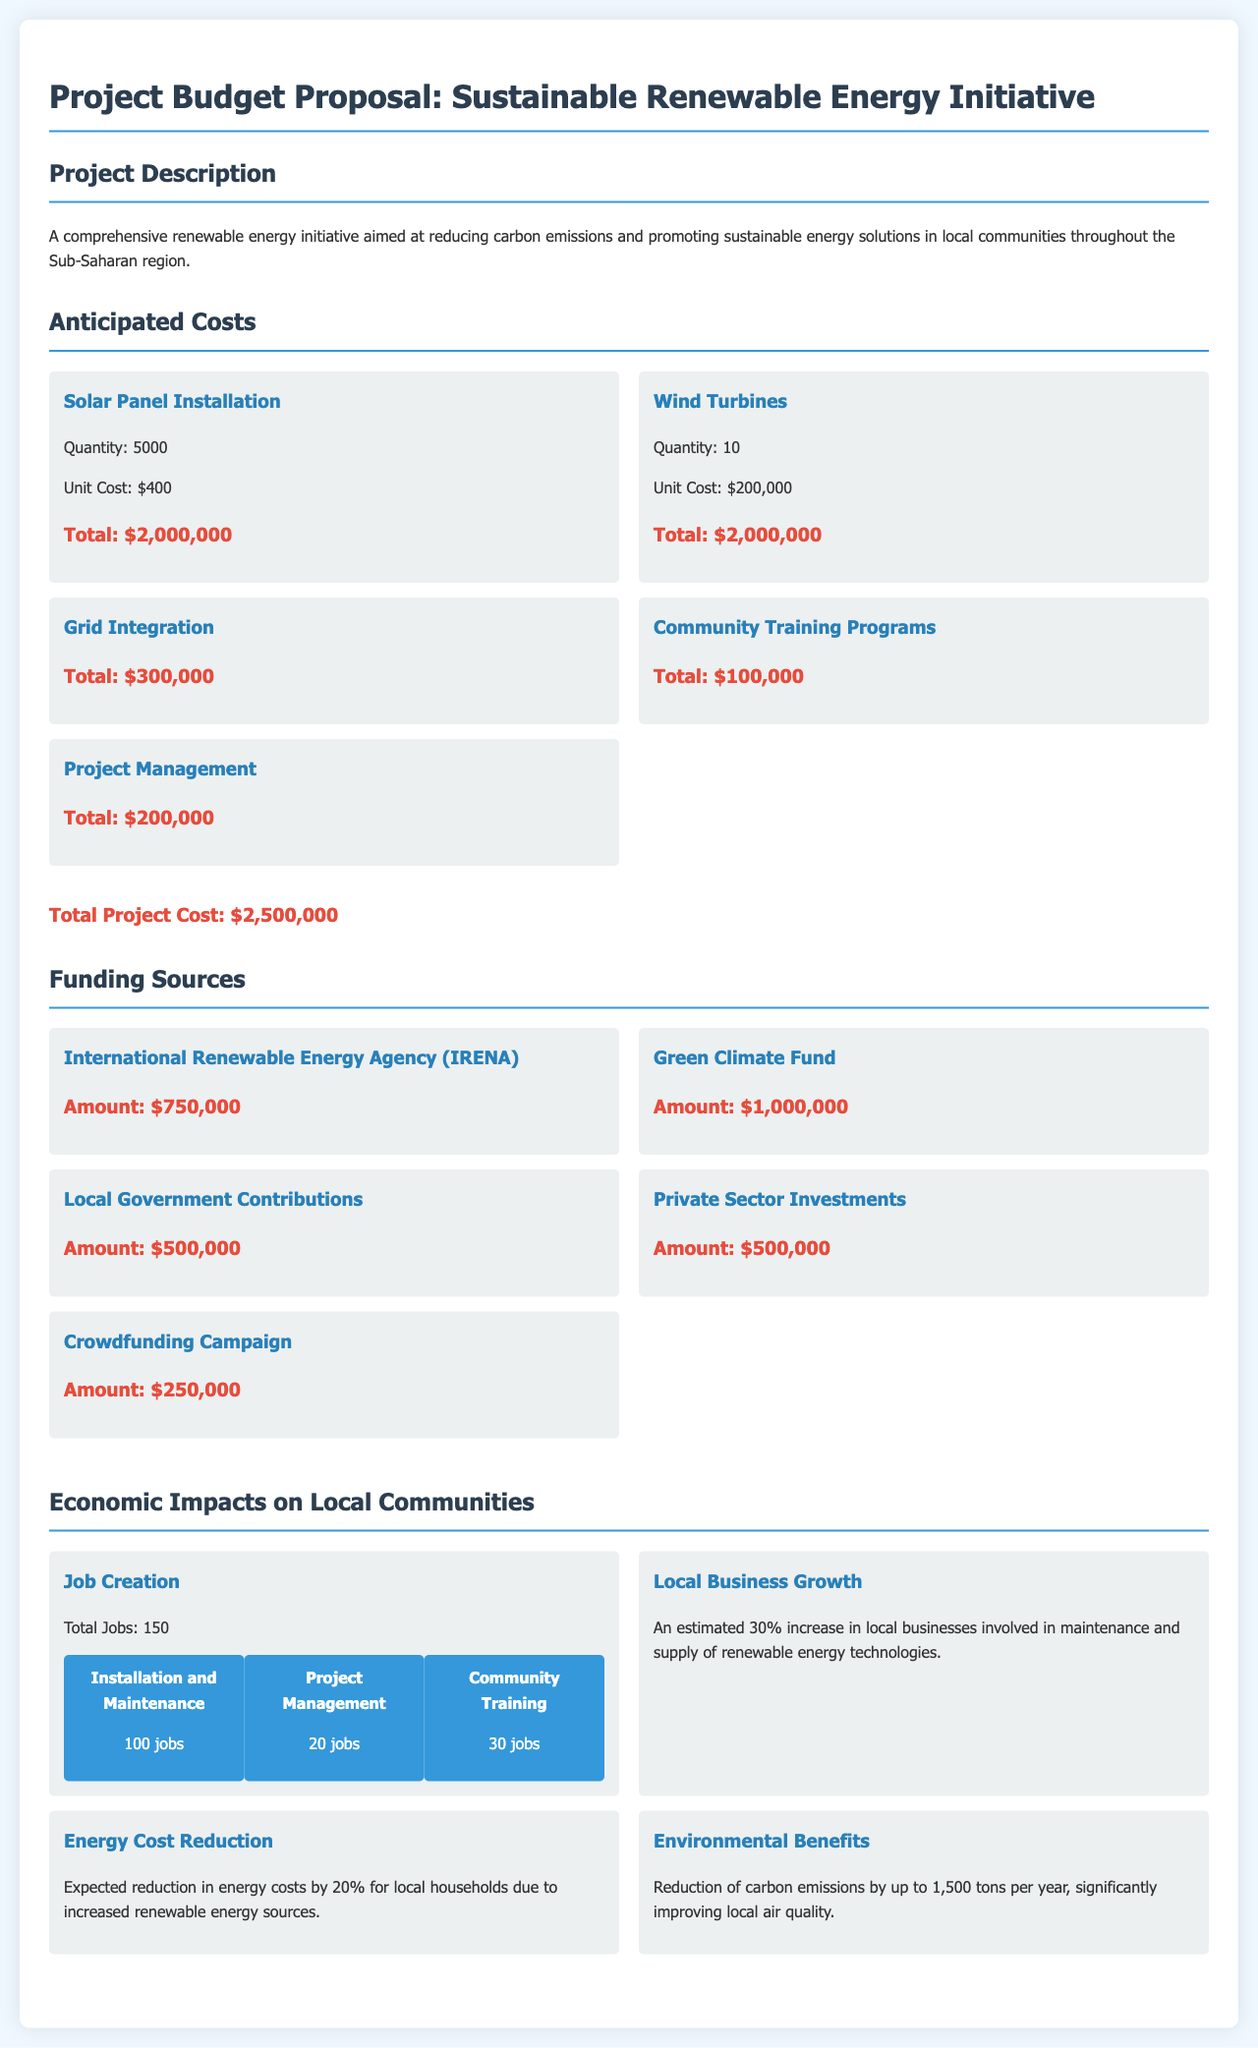What is the total project cost? The total project cost is calculated from the anticipated costs mentioned in the document, which sums up to $2,500,000.
Answer: $2,500,000 How many solar panels will be installed? The document states that 5000 solar panels are to be installed as part of the project.
Answer: 5000 Which organization is providing $750,000 in funding? The funding source of $750,000 is identified as the International Renewable Energy Agency (IRENA) in the document.
Answer: International Renewable Energy Agency (IRENA) What percentage reduction in energy costs for local households is expected? The document indicates that local households are expected to see a 20% reduction in energy costs due to the project.
Answer: 20% How many total jobs will be created through this initiative? The total number of jobs created as part of the initiative is stated as 150 jobs in the economic impacts section of the document.
Answer: 150 What is the amount contributed by the Green Climate Fund? The Green Climate Fund is mentioned as contributing $1,000,000 to the project in the funding sources section.
Answer: $1,000,000 What is the anticipated reduction of carbon emissions per year? According to the document, the anticipated reduction of carbon emissions is up to 1,500 tons annually.
Answer: 1,500 tons How many jobs are associated with installation and maintenance? The document specifies that 100 jobs are projected to be created for installation and maintenance within the initiative.
Answer: 100 What will be the estimated increase in local businesses involved in renewable energy? The economic impacts indicate an estimated 30% increase in local businesses involved in maintenance and supply of renewable energy technologies.
Answer: 30% 